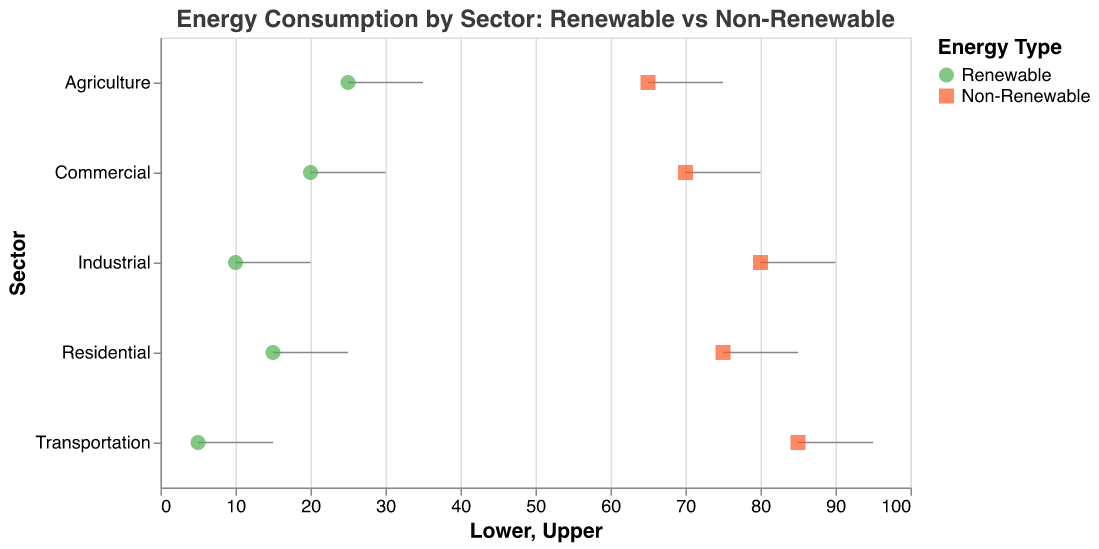What is the title of the figure? The title is typically displayed at the top center of the figure. In this case, it says: *"Energy Consumption by Sector: Renewable vs Non-Renewable"*.
Answer: "Energy Consumption by Sector: Renewable vs Non-Renewable" How many sectors are represented in the figure? The y-axis lists the sectors in the figure, and there are five distinct categories labeled as **Residential, Commercial, Industrial, Transportation, and Agriculture**.
Answer: 5 What color represents renewable energy consumption? The legend in the figure identifies the colors linked to each type of energy. Renewable energy is marked with the color green.
Answer: Green Which sector has the highest upper bound for non-renewable energy consumption? By observing the upper ends of the non-renewable energy consumption ranges (small squares), Transportation has the highest upper bound at 95%.
Answer: Transportation What is the range of renewable energy consumption in the Commercial sector? For the Commercial sector, the green line (representing renewable energy) spans from 20% to 30% on the x-axis.
Answer: 20% to 30% Which sector has the smallest range of renewable energy consumption? By examining the width of the green lines, the Industrial sector has the smallest range, spanning from 10% to 20%, a range of just 10%.
Answer: Industrial How does the range of renewable energy consumption in the Agriculture sector compare to the Residential sector? The Agriculture sector's renewable range (25% to 35%) spans 10 percentage points, while the Residential sector’s range (15% to 25%) also spans 10 percentage points. They both cover a range of 10 percentage points, but Agriculture is higher.
Answer: Both cover a 10% range, but Agriculture is higher By how much is the lower bound of renewable energy consumption in Residential sector higher than in Transportation sector? The lower bound of renewable in the Residential sector is 15% and in Transportation, it is 5%. The difference is 15% - 5%.
Answer: 10% Which sector shows the biggest gap between renewable and non-renewable energy consumption? By looking at the ranges, the Transportation sector has the widest gap, with non-renewable from 85% to 95% (a 10% range) and renewable from 5% to 15% (also a 10% range), but with a spacing gap of 70%.
Answer: Transportation What is the median percentage range for non-renewable energy consumption across all sectors? To find the median, list all upper and lower bounds for non-renewable energy percentages: 75-85 (Residential), 70-80 (Commercial), 80-90 (Industrial), 85-95 (Transportation), 65-75 (Agriculture). The median is in the middle of these values.
Answer: 70-80 